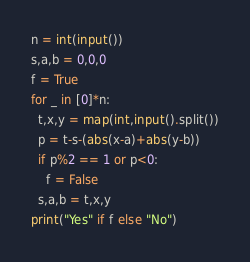Convert code to text. <code><loc_0><loc_0><loc_500><loc_500><_Python_>n = int(input())
s,a,b = 0,0,0
f = True
for _ in [0]*n:
  t,x,y = map(int,input().split())
  p = t-s-(abs(x-a)+abs(y-b))
  if p%2 == 1 or p<0:
    f = False
  s,a,b = t,x,y
print("Yes" if f else "No")</code> 